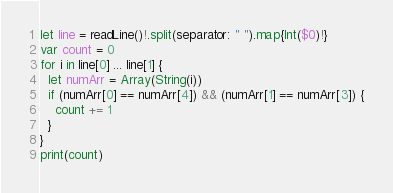<code> <loc_0><loc_0><loc_500><loc_500><_Swift_>let line = readLine()!.split(separator: " ").map{Int($0)!}
var count = 0
for i in line[0] ... line[1] {
  let numArr = Array(String(i))
  if (numArr[0] == numArr[4]) && (numArr[1] == numArr[3]) {
    count += 1
  }
}
print(count)</code> 